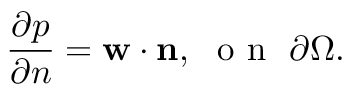<formula> <loc_0><loc_0><loc_500><loc_500>\frac { \partial p } { \partial n } = w \cdot n , \ o n \ \partial \Omega .</formula> 